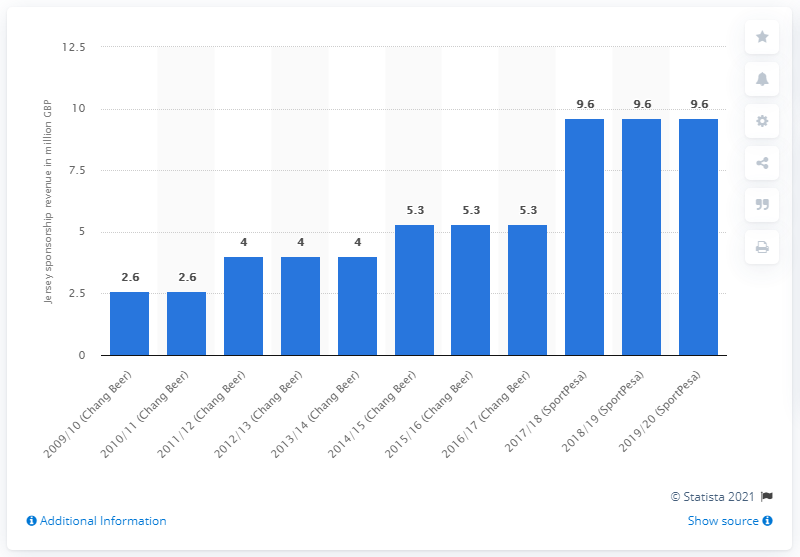Indicate a few pertinent items in this graphic. In the 2019/20 season, Everton FC received a total of 9.6 million pounds from SportPesa as part of their sponsorship agreement. 